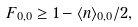Convert formula to latex. <formula><loc_0><loc_0><loc_500><loc_500>F _ { 0 , 0 } \geq 1 - \langle n \rangle _ { 0 , 0 } / 2 ,</formula> 